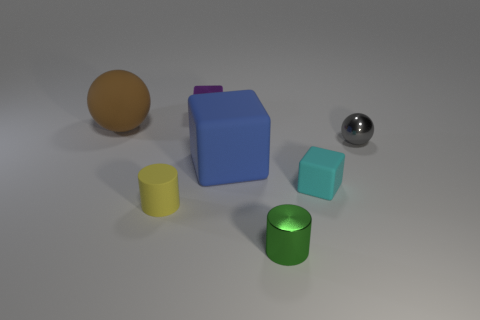Subtract all matte cubes. How many cubes are left? 1 Add 2 small yellow rubber blocks. How many objects exist? 9 Subtract all balls. How many objects are left? 5 Subtract all gray blocks. Subtract all blue balls. How many blocks are left? 3 Add 7 small rubber cylinders. How many small rubber cylinders exist? 8 Subtract 1 cyan blocks. How many objects are left? 6 Subtract all tiny red metal cylinders. Subtract all yellow things. How many objects are left? 6 Add 3 purple objects. How many purple objects are left? 4 